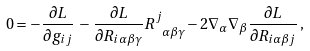Convert formula to latex. <formula><loc_0><loc_0><loc_500><loc_500>0 = - \frac { \partial L } { \partial g _ { i j } } \, - \, \frac { \partial L } { \partial R _ { i \alpha \beta \gamma } } R ^ { j } _ { \ \alpha \beta \gamma } - 2 \nabla _ { \alpha } \nabla _ { \beta } \frac { \partial L } { \partial R _ { i \alpha \beta j } } \, ,</formula> 